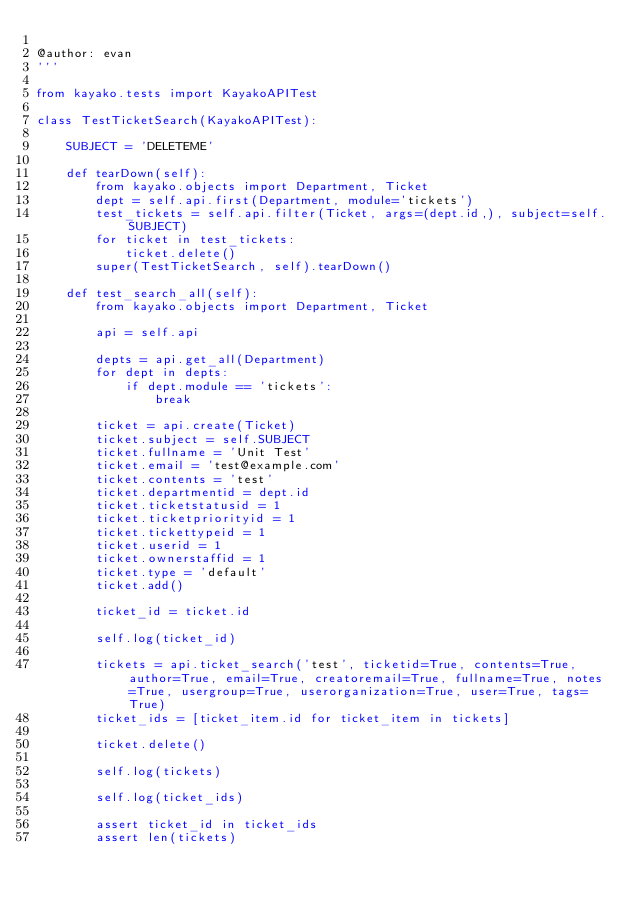<code> <loc_0><loc_0><loc_500><loc_500><_Python_>
@author: evan
'''

from kayako.tests import KayakoAPITest

class TestTicketSearch(KayakoAPITest):

    SUBJECT = 'DELETEME'

    def tearDown(self):
        from kayako.objects import Department, Ticket
        dept = self.api.first(Department, module='tickets')
        test_tickets = self.api.filter(Ticket, args=(dept.id,), subject=self.SUBJECT)
        for ticket in test_tickets:
            ticket.delete()
        super(TestTicketSearch, self).tearDown()

    def test_search_all(self):
        from kayako.objects import Department, Ticket

        api = self.api

        depts = api.get_all(Department)
        for dept in depts:
            if dept.module == 'tickets':
                break

        ticket = api.create(Ticket)
        ticket.subject = self.SUBJECT
        ticket.fullname = 'Unit Test'
        ticket.email = 'test@example.com'
        ticket.contents = 'test'
        ticket.departmentid = dept.id
        ticket.ticketstatusid = 1
        ticket.ticketpriorityid = 1
        ticket.tickettypeid = 1
        ticket.userid = 1
        ticket.ownerstaffid = 1
        ticket.type = 'default'
        ticket.add()

        ticket_id = ticket.id

        self.log(ticket_id)

        tickets = api.ticket_search('test', ticketid=True, contents=True, author=True, email=True, creatoremail=True, fullname=True, notes=True, usergroup=True, userorganization=True, user=True, tags=True)
        ticket_ids = [ticket_item.id for ticket_item in tickets]

        ticket.delete()

        self.log(tickets)

        self.log(ticket_ids)

        assert ticket_id in ticket_ids
        assert len(tickets)

</code> 